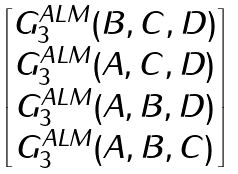Convert formula to latex. <formula><loc_0><loc_0><loc_500><loc_500>\begin{bmatrix} G _ { 3 } ^ { A L M } ( B , C , D ) \\ G _ { 3 } ^ { A L M } ( A , C , D ) \\ G _ { 3 } ^ { A L M } ( A , B , D ) \\ G _ { 3 } ^ { A L M } ( A , B , C ) \end{bmatrix}</formula> 